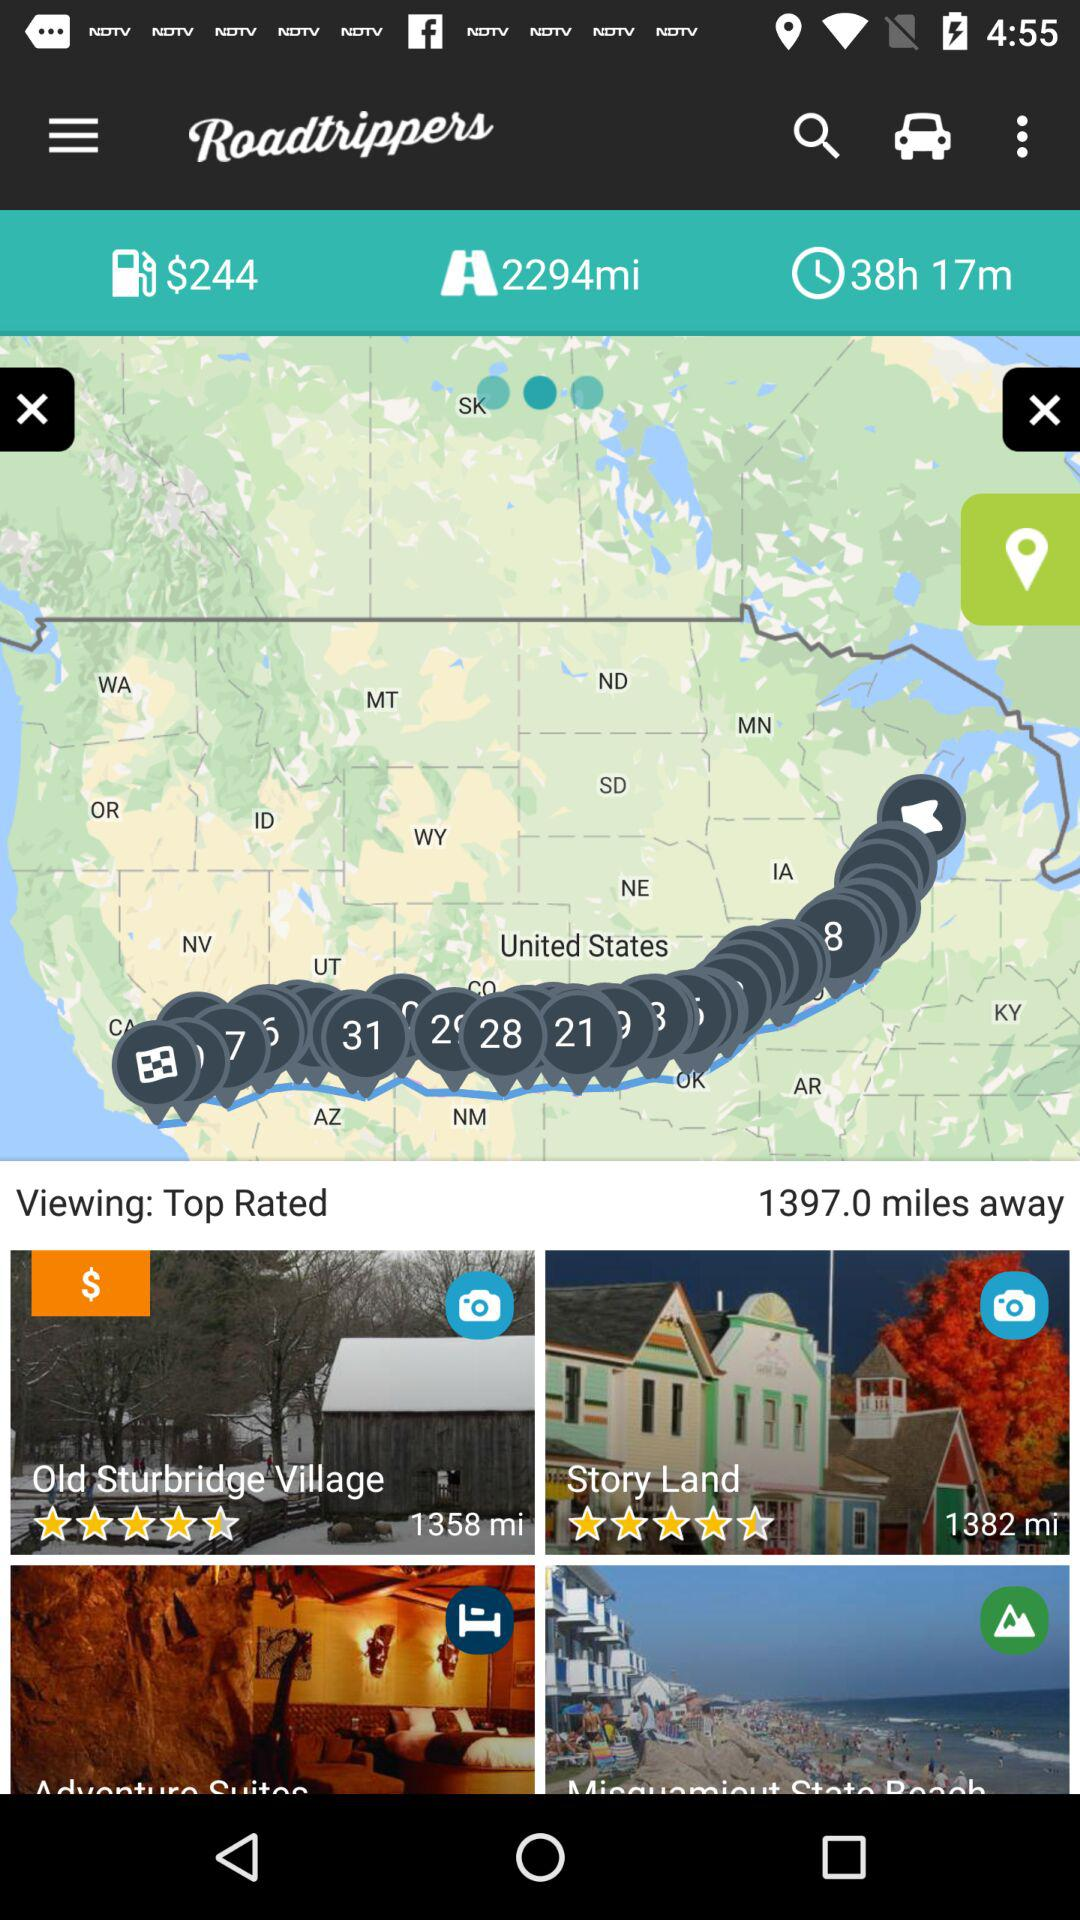What is the rating of "Story Land"? The rating of "Story Land" is 4.5 stars. 